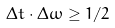<formula> <loc_0><loc_0><loc_500><loc_500>\Delta t \cdot \Delta \omega \geq 1 / 2</formula> 